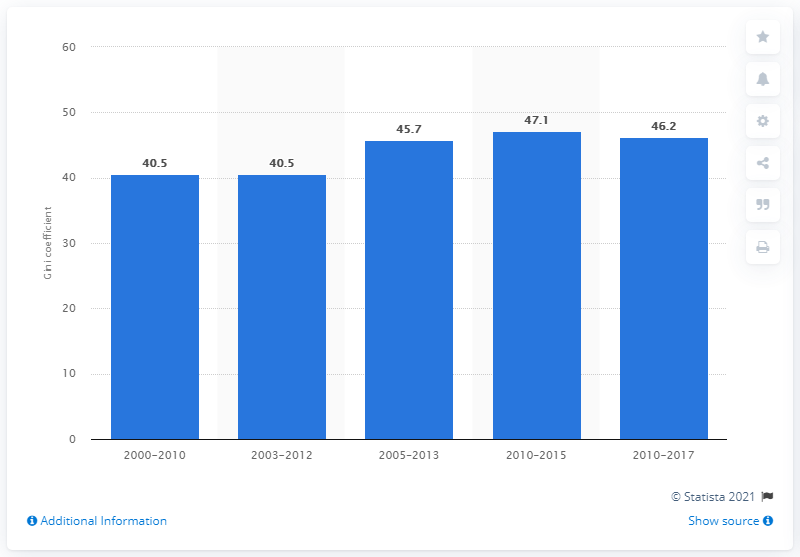Outline some significant characteristics in this image. In 2015, Nicaragua's Gini coefficient was 47.1, indicating a moderate level of income inequality. 